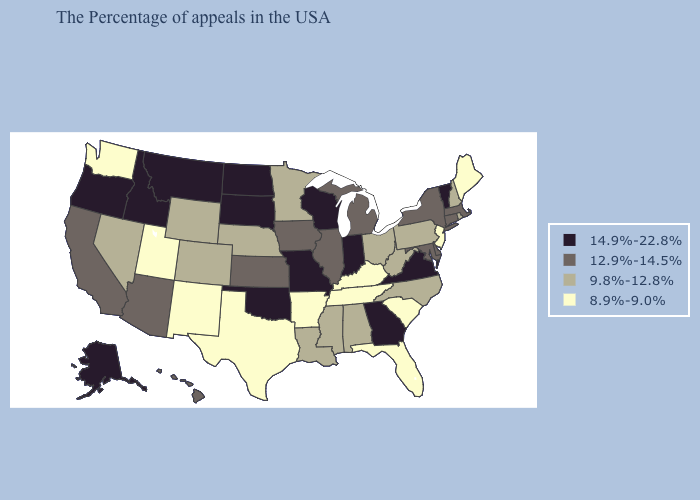Does Kentucky have the same value as Montana?
Keep it brief. No. Does North Dakota have the highest value in the USA?
Concise answer only. Yes. Does the map have missing data?
Answer briefly. No. Among the states that border New Mexico , which have the lowest value?
Concise answer only. Texas, Utah. What is the value of Pennsylvania?
Concise answer only. 9.8%-12.8%. Name the states that have a value in the range 12.9%-14.5%?
Short answer required. Massachusetts, Connecticut, New York, Delaware, Maryland, Michigan, Illinois, Iowa, Kansas, Arizona, California, Hawaii. What is the value of Rhode Island?
Concise answer only. 9.8%-12.8%. Among the states that border Oregon , does Idaho have the lowest value?
Write a very short answer. No. What is the value of Maryland?
Keep it brief. 12.9%-14.5%. Which states have the lowest value in the USA?
Short answer required. Maine, New Jersey, South Carolina, Florida, Kentucky, Tennessee, Arkansas, Texas, New Mexico, Utah, Washington. Does Illinois have the lowest value in the USA?
Short answer required. No. What is the lowest value in the USA?
Be succinct. 8.9%-9.0%. Which states have the lowest value in the West?
Be succinct. New Mexico, Utah, Washington. Does Massachusetts have the lowest value in the USA?
Answer briefly. No. Does the first symbol in the legend represent the smallest category?
Give a very brief answer. No. 